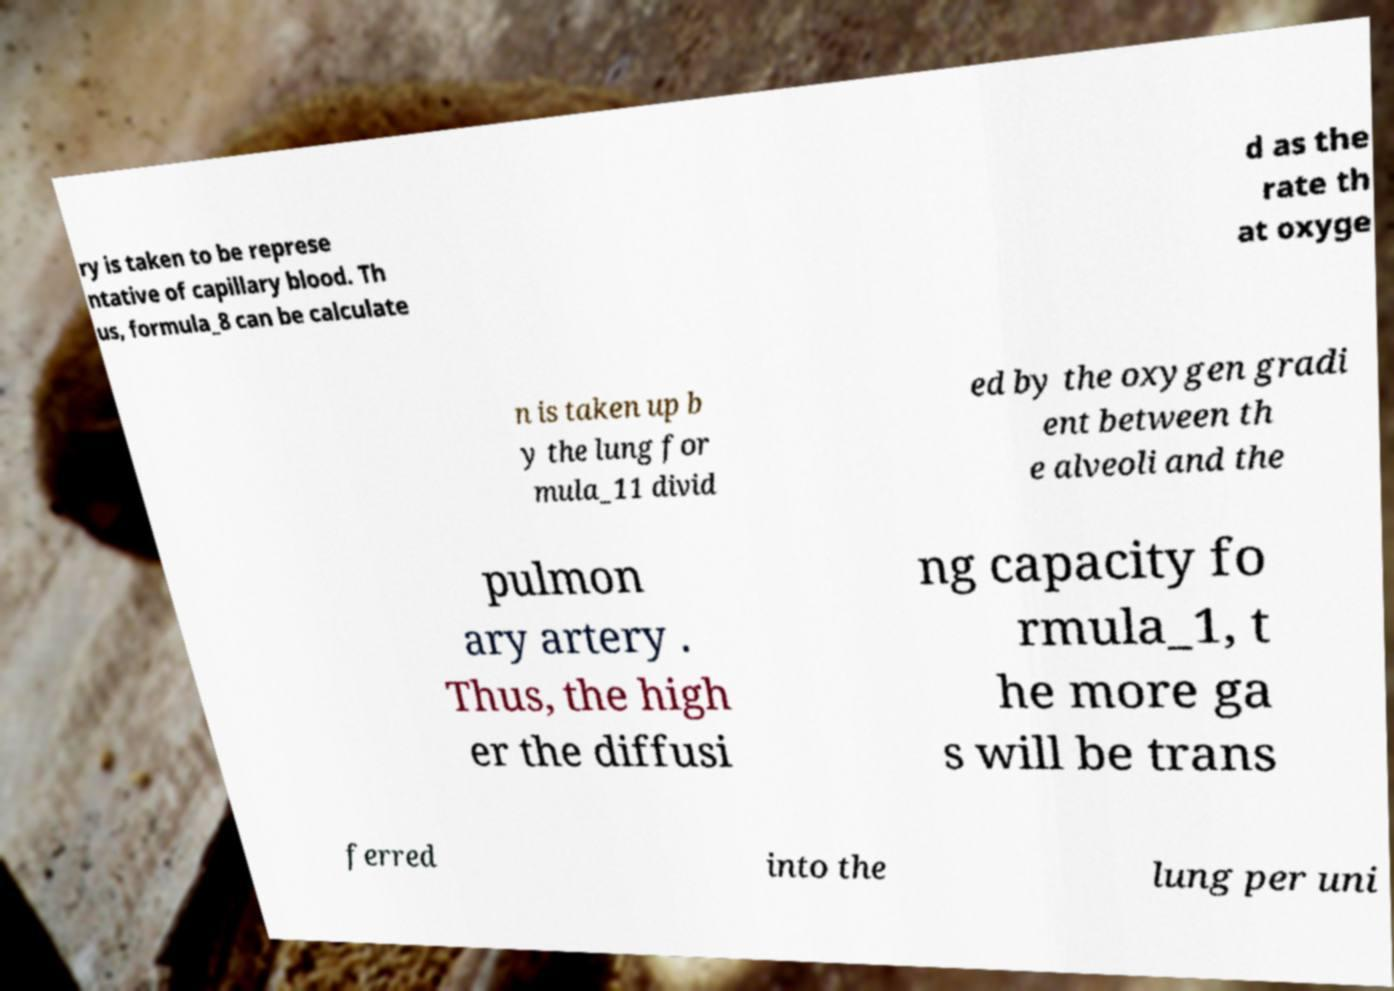Could you extract and type out the text from this image? ry is taken to be represe ntative of capillary blood. Th us, formula_8 can be calculate d as the rate th at oxyge n is taken up b y the lung for mula_11 divid ed by the oxygen gradi ent between th e alveoli and the pulmon ary artery . Thus, the high er the diffusi ng capacity fo rmula_1, t he more ga s will be trans ferred into the lung per uni 